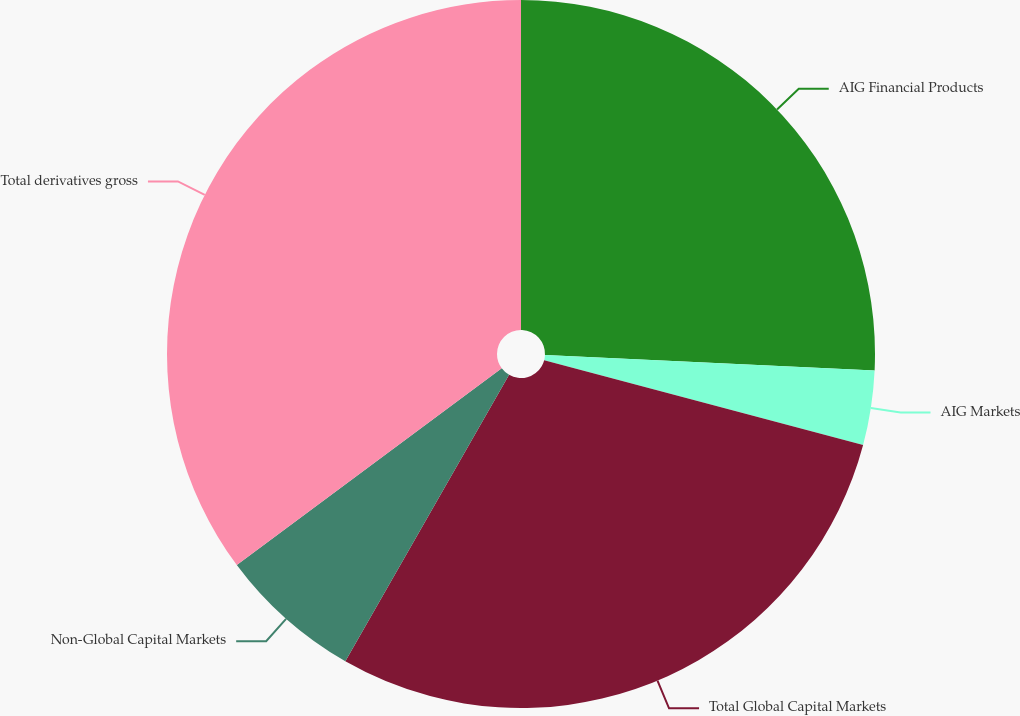Convert chart. <chart><loc_0><loc_0><loc_500><loc_500><pie_chart><fcel>AIG Financial Products<fcel>AIG Markets<fcel>Total Global Capital Markets<fcel>Non-Global Capital Markets<fcel>Total derivatives gross<nl><fcel>25.74%<fcel>3.4%<fcel>29.13%<fcel>6.57%<fcel>35.17%<nl></chart> 